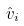Convert formula to latex. <formula><loc_0><loc_0><loc_500><loc_500>\hat { v } _ { i }</formula> 